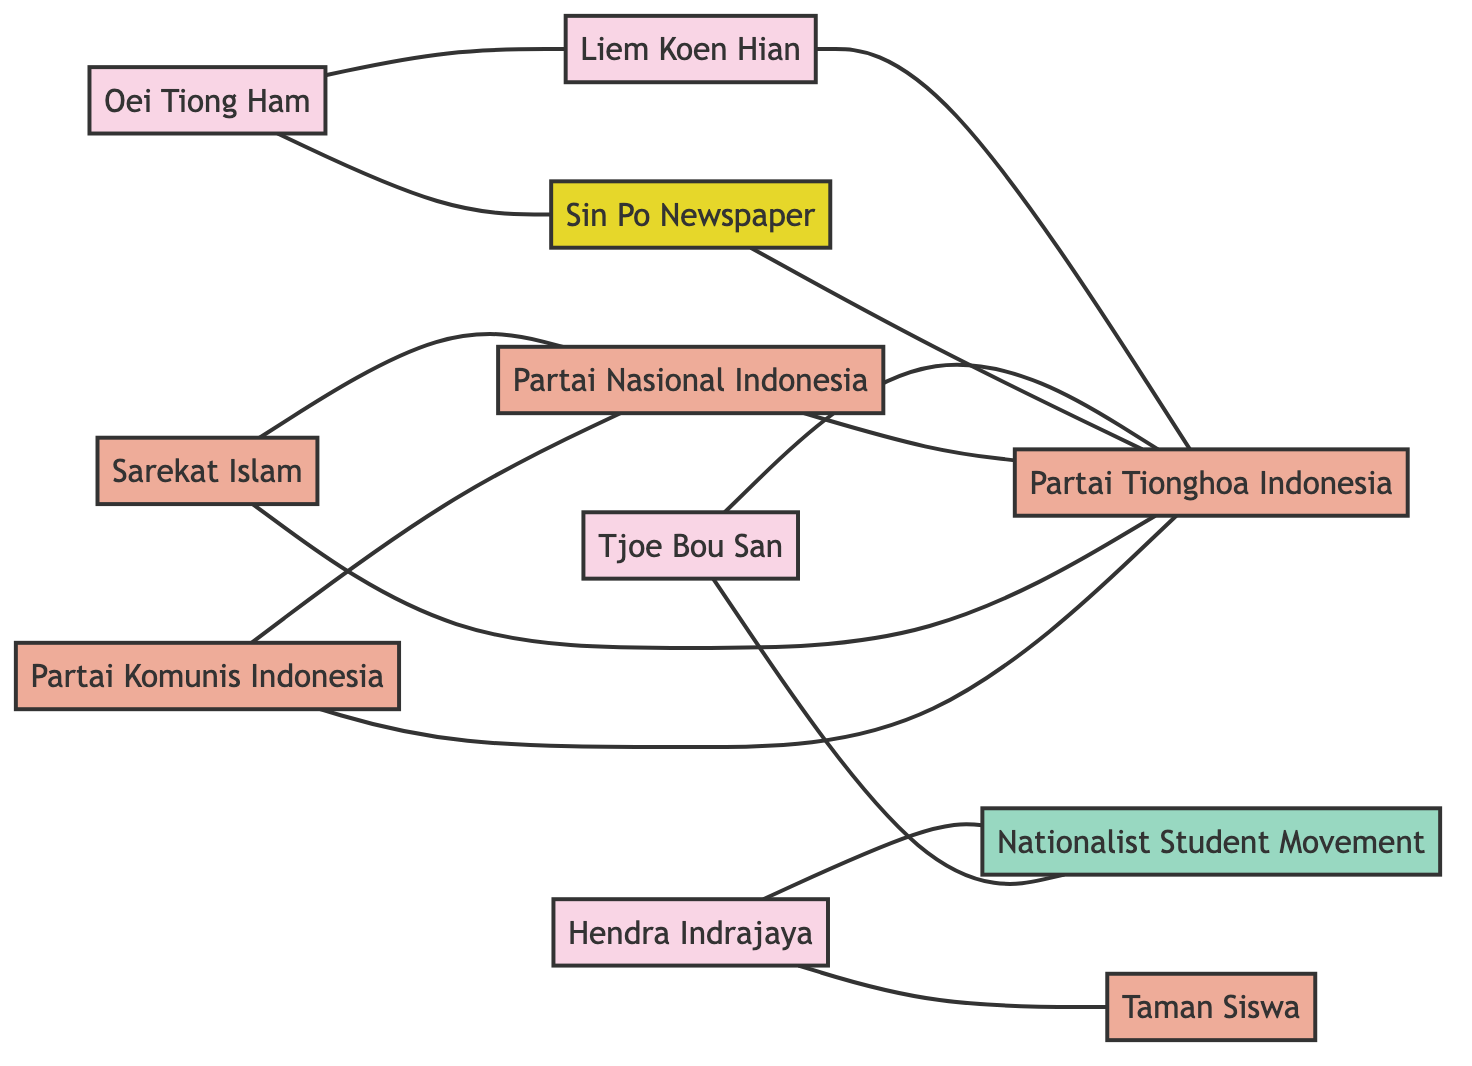What is the total number of nodes in the diagram? By counting the unique entries in the "nodes" section of the data, we find that there are 11 distinct nodes represented in the diagram.
Answer: 11 Who is connected to Liem Koen Hian? Liem Koen Hian is directly connected to Oei Tiong Ham and PTI, as indicated by the edges linking these entities.
Answer: Oei Tiong Ham, PTI Which organization is indicated as a member of the PTI? The diagram shows Tjoe Bou San as a member of the Partai Tionghoa Indonesia (PTI) through a direct edge representing their relationship.
Answer: Tjoe Bou San How many connections does the Sin Po Newspaper have? Sin Po Newspaper has three direct edges connected: to PTI, to Oei Tiong Ham, and notably, it supports PTI. Counting these gives us three connections.
Answer: 3 What is the relationship between PKI and PNI? The diagram indicates that PKI and PNI maintain an anti-colonial alliance, which reflects the nature of their collaboration in the context of the independence movement.
Answer: Anti-Colonial Alliance Which individual is the leader of the Nationalist Student Movement? From the diagram, we see that Hendra Indrajaya is linked to the Nationalist Student Movement as its leader, indicating his prominent role in that organization.
Answer: Hendra Indrajaya How is Sarekat Islam (SI) connected to Partai Nasional Indonesia (PNI)? The diagram illustrates that SI is connected to PNI as a coalition member, highlighting their partnership within the broader anti-colonial efforts.
Answer: Coalition Member Identify the individual associated with both Taman Siswa and Nationalist Student Movement. The connection is made clear through edges linking Hendra Indrajaya to both Taman Siswa and the Nationalist Student Movement, indicating his involvement in both organizations.
Answer: Hendra Indrajaya What type of support does Oei Tiong Ham provide to Sin Po Newspaper? The edge connecting Oei Tiong Ham to Sin Po indicates that he offers financial support, illustrating his engagement in funding for the press associated with the independence movement.
Answer: Financial Support 